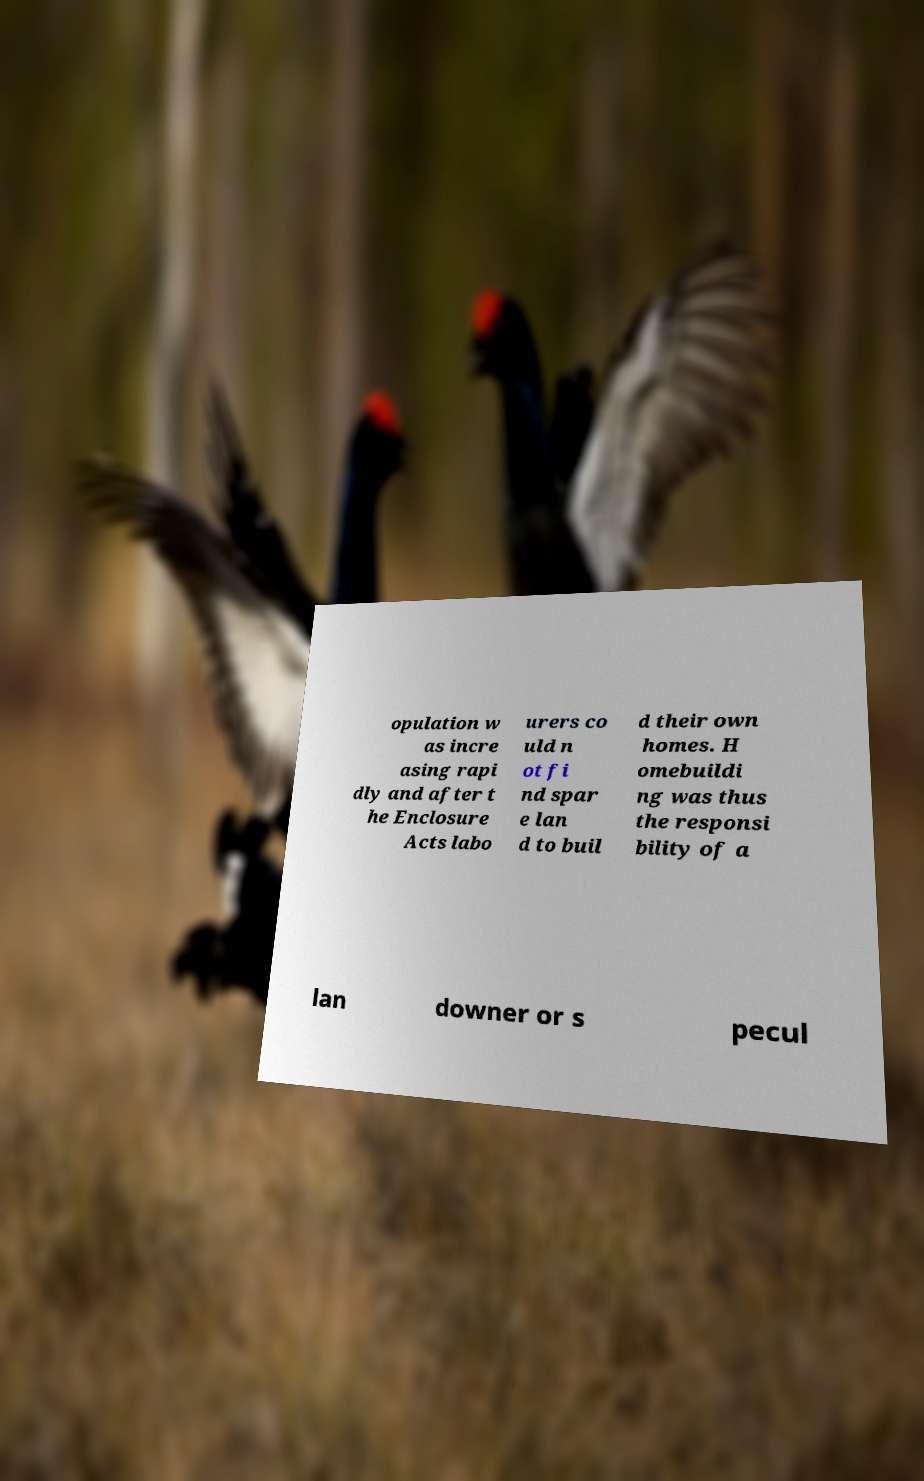What messages or text are displayed in this image? I need them in a readable, typed format. opulation w as incre asing rapi dly and after t he Enclosure Acts labo urers co uld n ot fi nd spar e lan d to buil d their own homes. H omebuildi ng was thus the responsi bility of a lan downer or s pecul 